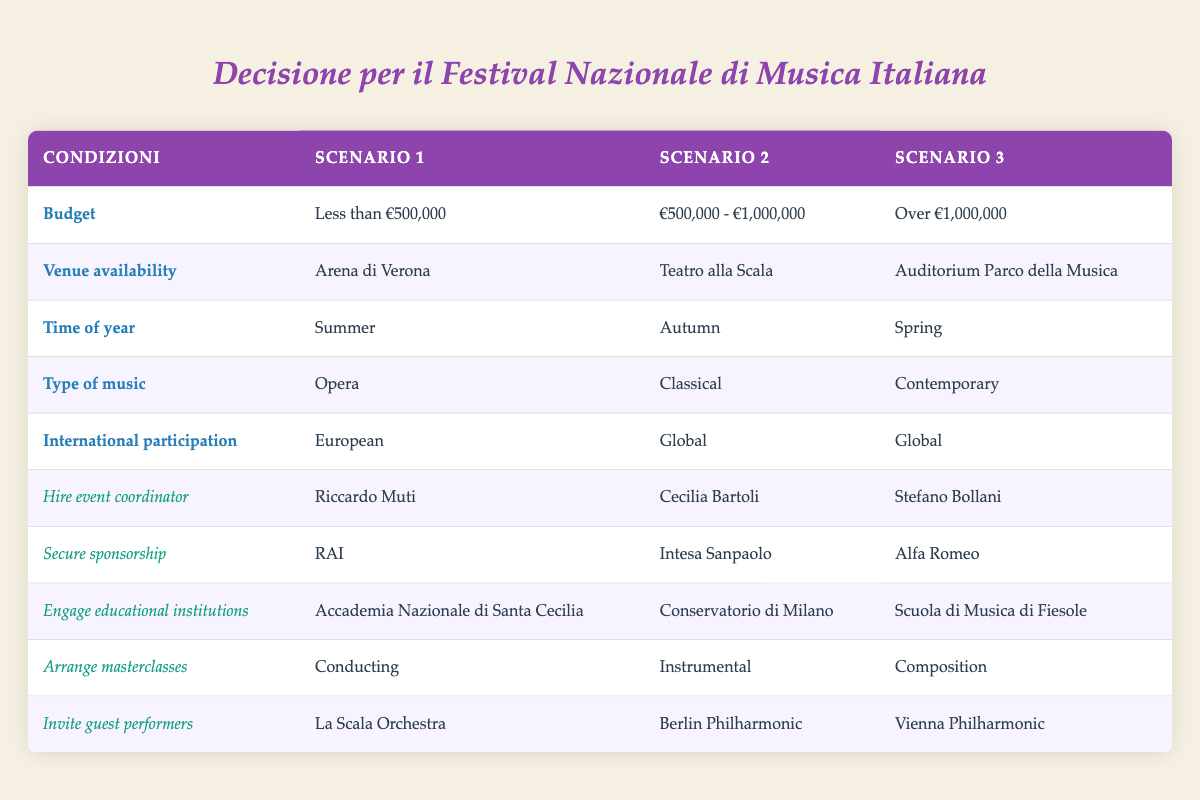What venue is used when the budget is less than €500,000? According to the table, under the conditions where the budget is less than €500,000, the venue selected is the Arena di Verona.
Answer: Arena di Verona Which event coordinator is hired for the scenario with a budget between €500,000 and €1,000,000? The table indicates that for the budget range of €500,000 - €1,000,000, the event coordinator engaged is Cecilia Bartoli.
Answer: Cecilia Bartoli Is the international participation in the autumn scenario Global? By examining the autumn scenario, it is noted that international participation is classified as Global.
Answer: Yes What type of music is featured at the festival when held in the spring with a budget over €1,000,000? The table specifies that for the spring season with a budget exceeding €1,000,000, the type of music showcased is Contemporary.
Answer: Contemporary Which masterclass is arranged when the budget is less than €500,000 and the venue is Arena di Verona? Upon reviewing the table, when the budget is less than €500,000 and the venue is Arena di Verona, the arranged masterclass is Conducting.
Answer: Conducting How many scenarios feature the Berlin Philharmonic as a guest performer? By inspecting the table, the Berlin Philharmonic appears in one scenario, specifically in the autumn scenario with a budget between €500,000 and €1,000,000.
Answer: One scenario If the venue chosen is Teatro alla Scala, which sponsorship is secured? The table shows that when Teatro alla Scala is the venue, the secured sponsorship is Intesa Sanpaolo.
Answer: Intesa Sanpaolo What are the actions taken for the autumn scenario based on the given conditions? The actions for the autumn scenario with a budget of €500,000 - €1,000,000 include hiring Cecilia Bartoli as the event coordinator, securing sponsorship from Intesa Sanpaolo, engaging the Conservatorio di Milano, arranging instrumental masterclasses, and inviting the Berlin Philharmonic.
Answer: Cecilia Bartoli, Intesa Sanpaolo, Conservatorio di Milano, Instrumental, Berlin Philharmonic 